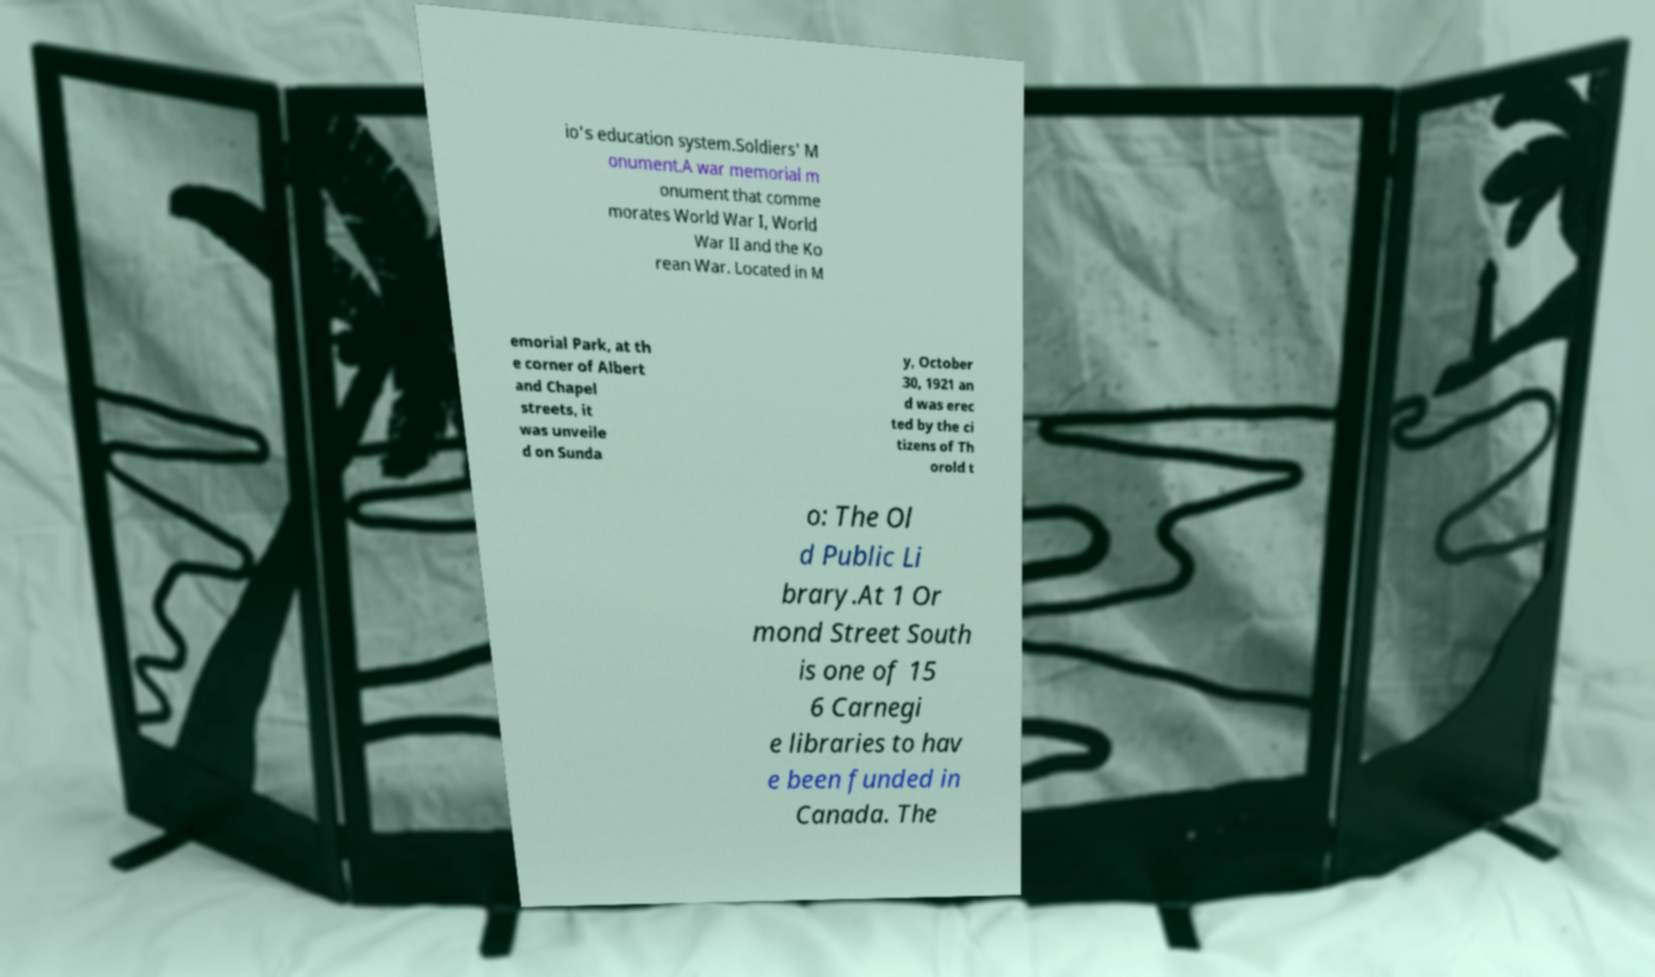For documentation purposes, I need the text within this image transcribed. Could you provide that? io's education system.Soldiers' M onument.A war memorial m onument that comme morates World War I, World War II and the Ko rean War. Located in M emorial Park, at th e corner of Albert and Chapel streets, it was unveile d on Sunda y, October 30, 1921 an d was erec ted by the ci tizens of Th orold t o: The Ol d Public Li brary.At 1 Or mond Street South is one of 15 6 Carnegi e libraries to hav e been funded in Canada. The 